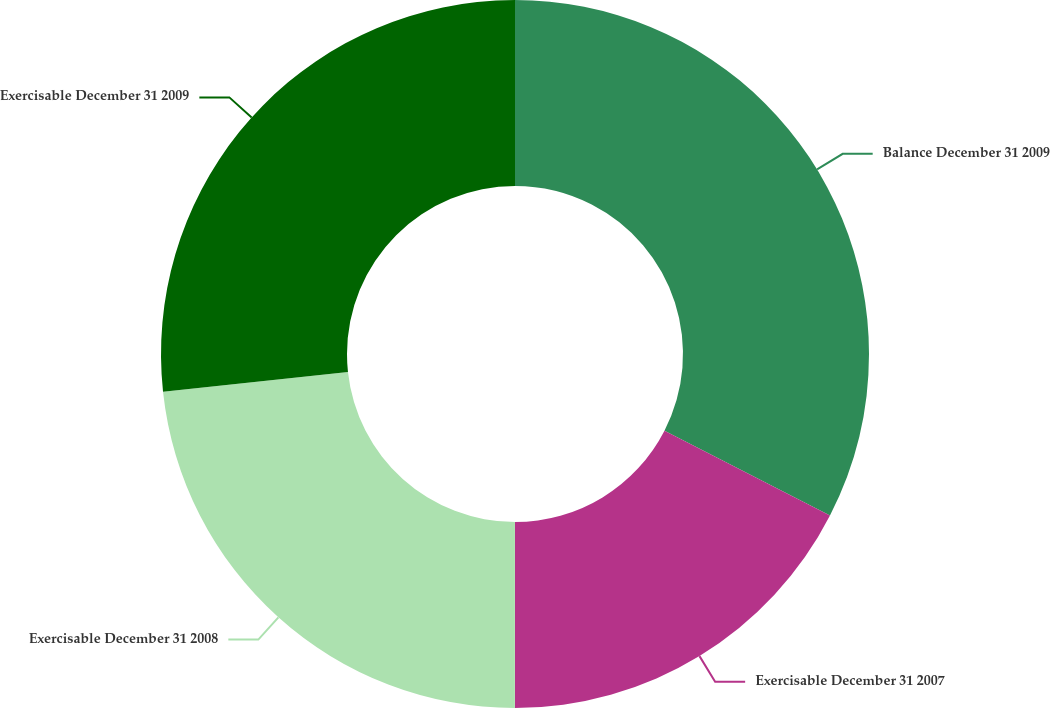Convert chart to OTSL. <chart><loc_0><loc_0><loc_500><loc_500><pie_chart><fcel>Balance December 31 2009<fcel>Exercisable December 31 2007<fcel>Exercisable December 31 2008<fcel>Exercisable December 31 2009<nl><fcel>32.54%<fcel>17.46%<fcel>23.29%<fcel>26.7%<nl></chart> 